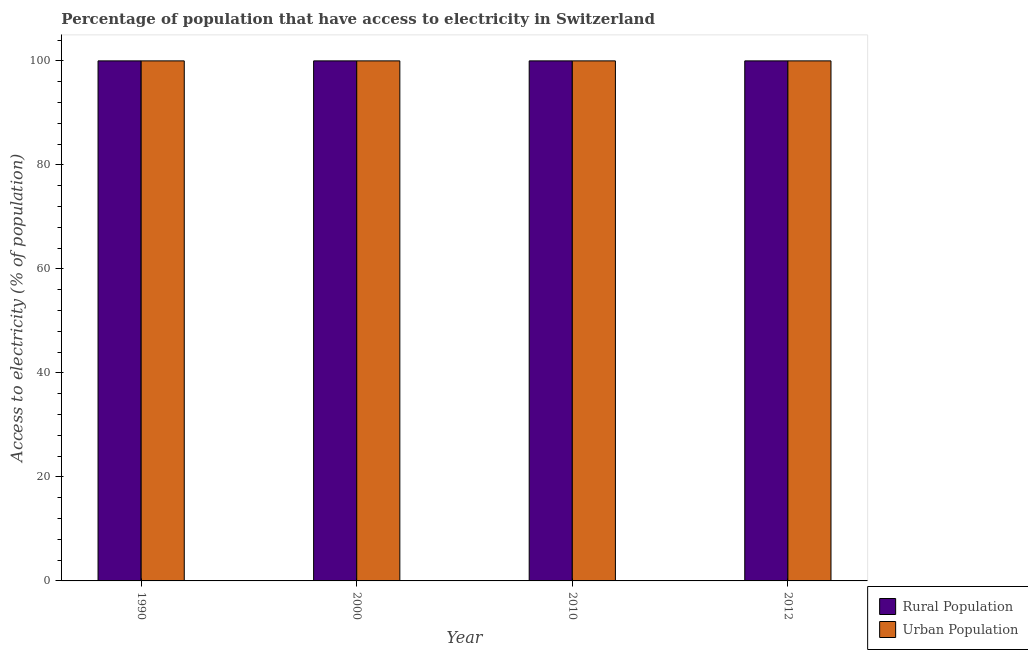How many groups of bars are there?
Your answer should be very brief. 4. Are the number of bars per tick equal to the number of legend labels?
Provide a short and direct response. Yes. Are the number of bars on each tick of the X-axis equal?
Offer a terse response. Yes. How many bars are there on the 1st tick from the right?
Your answer should be compact. 2. In how many cases, is the number of bars for a given year not equal to the number of legend labels?
Provide a short and direct response. 0. What is the percentage of urban population having access to electricity in 2000?
Offer a very short reply. 100. Across all years, what is the maximum percentage of urban population having access to electricity?
Provide a short and direct response. 100. Across all years, what is the minimum percentage of urban population having access to electricity?
Make the answer very short. 100. In which year was the percentage of rural population having access to electricity maximum?
Offer a terse response. 1990. In which year was the percentage of urban population having access to electricity minimum?
Your answer should be very brief. 1990. What is the total percentage of rural population having access to electricity in the graph?
Keep it short and to the point. 400. What is the difference between the percentage of urban population having access to electricity in 2000 and that in 2010?
Your answer should be very brief. 0. In the year 2000, what is the difference between the percentage of rural population having access to electricity and percentage of urban population having access to electricity?
Ensure brevity in your answer.  0. In how many years, is the percentage of rural population having access to electricity greater than 24 %?
Your answer should be very brief. 4. Is the percentage of urban population having access to electricity in 1990 less than that in 2010?
Offer a terse response. No. What is the difference between the highest and the lowest percentage of rural population having access to electricity?
Give a very brief answer. 0. In how many years, is the percentage of urban population having access to electricity greater than the average percentage of urban population having access to electricity taken over all years?
Give a very brief answer. 0. What does the 1st bar from the left in 2012 represents?
Your response must be concise. Rural Population. What does the 2nd bar from the right in 2012 represents?
Give a very brief answer. Rural Population. Are all the bars in the graph horizontal?
Offer a terse response. No. Are the values on the major ticks of Y-axis written in scientific E-notation?
Your answer should be very brief. No. What is the title of the graph?
Ensure brevity in your answer.  Percentage of population that have access to electricity in Switzerland. Does "Forest land" appear as one of the legend labels in the graph?
Offer a terse response. No. What is the label or title of the Y-axis?
Offer a very short reply. Access to electricity (% of population). What is the Access to electricity (% of population) of Rural Population in 2010?
Your answer should be compact. 100. What is the Access to electricity (% of population) in Urban Population in 2010?
Your answer should be compact. 100. Across all years, what is the maximum Access to electricity (% of population) of Rural Population?
Offer a very short reply. 100. Across all years, what is the maximum Access to electricity (% of population) in Urban Population?
Offer a very short reply. 100. What is the difference between the Access to electricity (% of population) of Urban Population in 1990 and that in 2000?
Provide a succinct answer. 0. What is the difference between the Access to electricity (% of population) in Rural Population in 1990 and that in 2010?
Offer a very short reply. 0. What is the difference between the Access to electricity (% of population) of Urban Population in 2000 and that in 2010?
Keep it short and to the point. 0. What is the difference between the Access to electricity (% of population) of Rural Population in 2000 and that in 2012?
Your response must be concise. 0. What is the difference between the Access to electricity (% of population) in Rural Population in 2010 and that in 2012?
Provide a succinct answer. 0. What is the difference between the Access to electricity (% of population) of Urban Population in 2010 and that in 2012?
Ensure brevity in your answer.  0. What is the difference between the Access to electricity (% of population) of Rural Population in 1990 and the Access to electricity (% of population) of Urban Population in 2000?
Keep it short and to the point. 0. What is the difference between the Access to electricity (% of population) of Rural Population in 1990 and the Access to electricity (% of population) of Urban Population in 2012?
Provide a succinct answer. 0. In the year 2000, what is the difference between the Access to electricity (% of population) of Rural Population and Access to electricity (% of population) of Urban Population?
Offer a very short reply. 0. In the year 2012, what is the difference between the Access to electricity (% of population) in Rural Population and Access to electricity (% of population) in Urban Population?
Ensure brevity in your answer.  0. What is the ratio of the Access to electricity (% of population) of Urban Population in 1990 to that in 2000?
Your answer should be compact. 1. What is the ratio of the Access to electricity (% of population) in Rural Population in 1990 to that in 2010?
Keep it short and to the point. 1. What is the ratio of the Access to electricity (% of population) of Urban Population in 1990 to that in 2010?
Provide a short and direct response. 1. What is the ratio of the Access to electricity (% of population) of Rural Population in 2000 to that in 2010?
Your answer should be compact. 1. What is the ratio of the Access to electricity (% of population) of Rural Population in 2000 to that in 2012?
Make the answer very short. 1. What is the ratio of the Access to electricity (% of population) in Urban Population in 2000 to that in 2012?
Your answer should be very brief. 1. What is the ratio of the Access to electricity (% of population) in Rural Population in 2010 to that in 2012?
Provide a short and direct response. 1. What is the ratio of the Access to electricity (% of population) of Urban Population in 2010 to that in 2012?
Give a very brief answer. 1. What is the difference between the highest and the second highest Access to electricity (% of population) in Urban Population?
Your response must be concise. 0. 